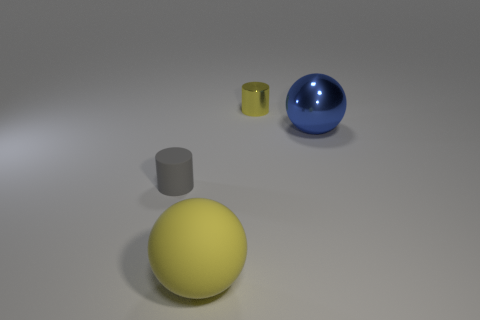Is the number of metal balls greater than the number of yellow things?
Provide a succinct answer. No. The large thing that is to the right of the big yellow rubber object has what shape?
Make the answer very short. Sphere. What number of other big rubber objects are the same shape as the gray thing?
Your response must be concise. 0. There is a ball that is behind the rubber object that is left of the big matte thing; what size is it?
Provide a succinct answer. Large. How many yellow objects are either cylinders or big matte things?
Ensure brevity in your answer.  2. Are there fewer cylinders that are to the left of the rubber ball than small yellow cylinders that are in front of the metallic sphere?
Make the answer very short. No. There is a matte ball; is it the same size as the cylinder to the left of the small metal cylinder?
Your answer should be very brief. No. How many yellow rubber spheres are the same size as the blue metal ball?
Make the answer very short. 1. How many tiny objects are yellow shiny things or purple cylinders?
Provide a short and direct response. 1. Are there any large green metal cubes?
Provide a short and direct response. No. 